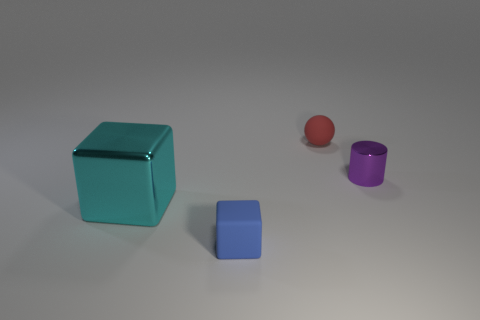Add 1 red objects. How many objects exist? 5 Subtract all cylinders. How many objects are left? 3 Subtract 1 cyan cubes. How many objects are left? 3 Subtract all cyan objects. Subtract all small purple objects. How many objects are left? 2 Add 3 small things. How many small things are left? 6 Add 4 matte objects. How many matte objects exist? 6 